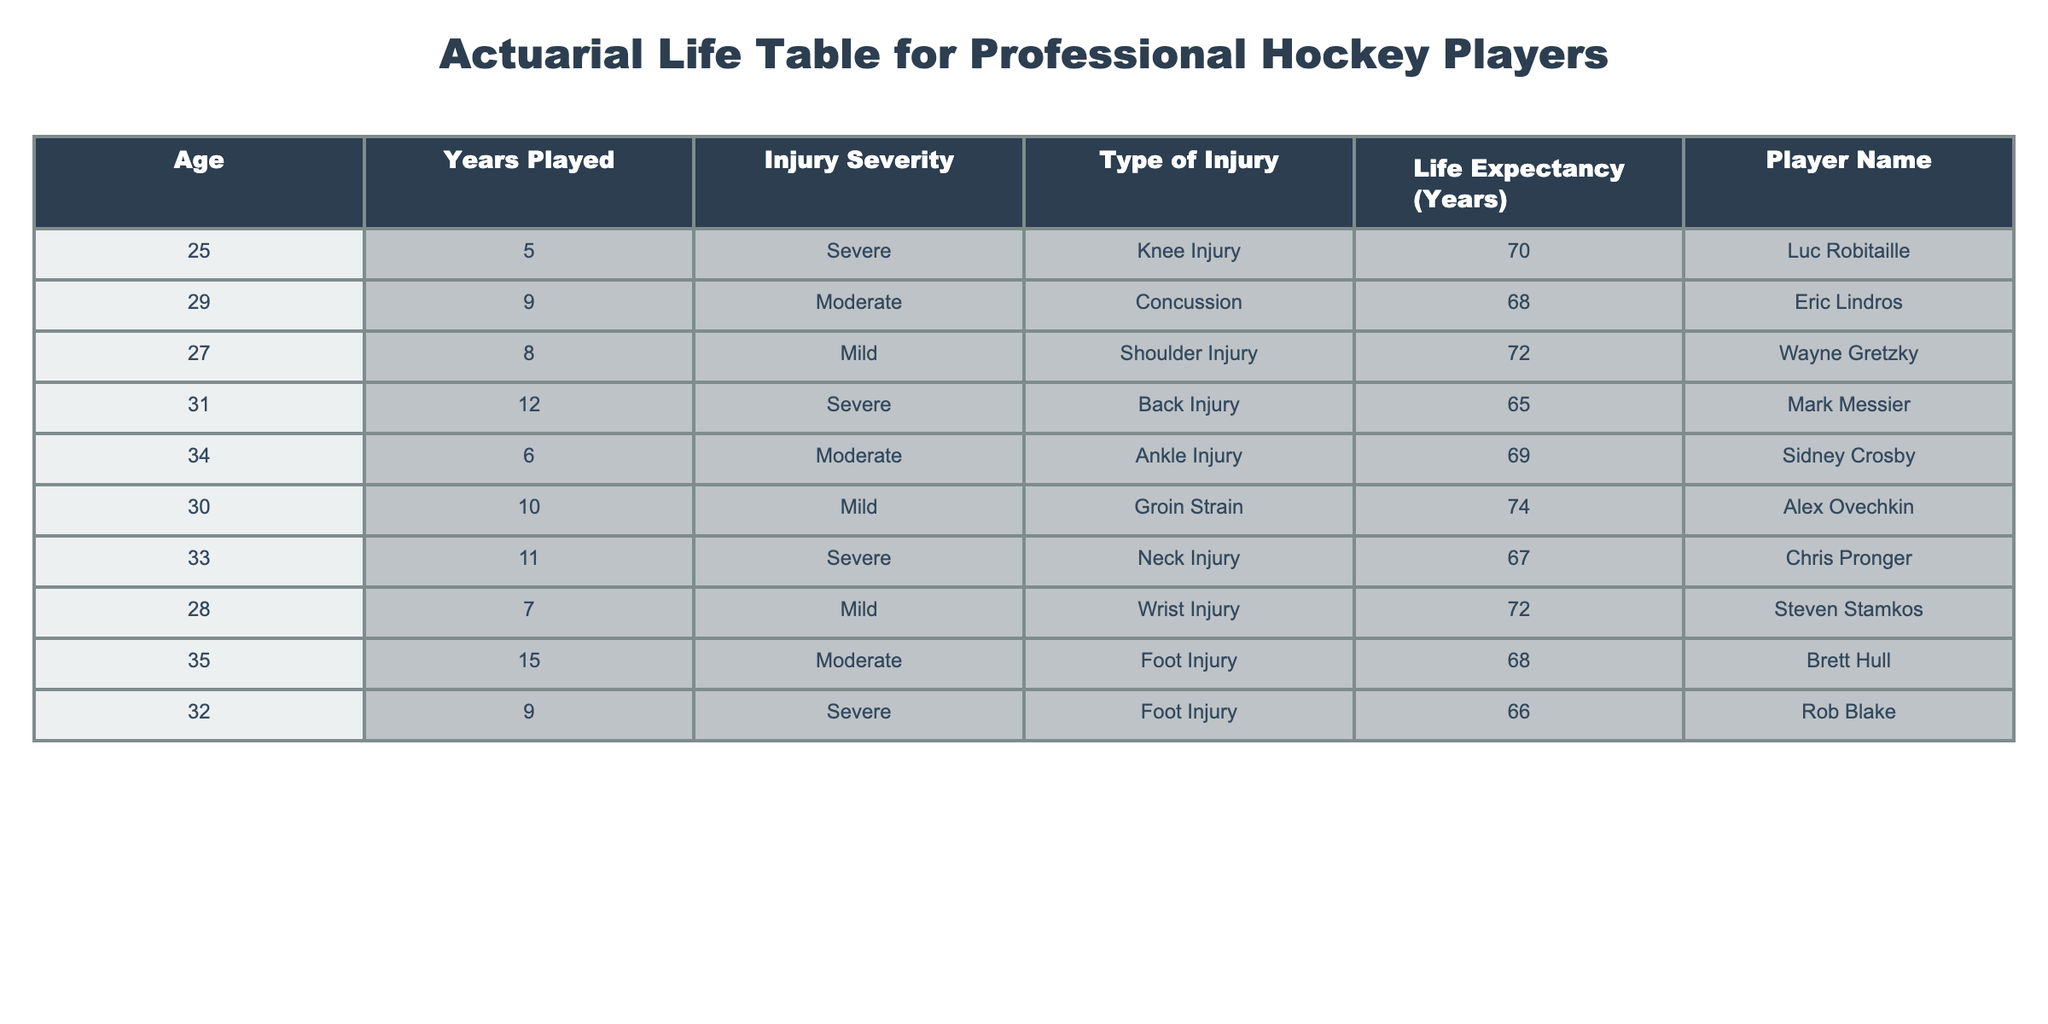What is the life expectancy of Luc Robitaille? Luc Robitaille's life expectancy, as stated in the table, is listed under the "Life Expectancy (Years)" column. His value is 70, which directly reflects the information provided.
Answer: 70 Which player has the highest life expectancy? To find this, we need to look at the "Life Expectancy (Years)" column and identify the maximum value. Upon reviewing the table, we see that Alex Ovechkin has the highest value of 74 years.
Answer: 74 What is the average life expectancy of players with severe injuries? We identify players with "Severe" under the "Injury Severity" column and note their life expectancies: Luc Robitaille (70), Mark Messier (65), Chris Pronger (67), and Rob Blake (66). Summing these gives 70 + 65 + 67 + 66 = 268. Now we divide this by the number of players (4) to find the average: 268 / 4 = 67.
Answer: 67 Is it true that all players with mild injuries have a life expectancy greater than 70 years? We check the "Injury Severity" column and find the players with "Mild" injuries: Wayne Gretzky (72), Alex Ovechkin (74), and Steven Stamkos (72). All three have values above 70 years; therefore, the statement is true.
Answer: Yes Which player had a career length of over 10 years and what was their life expectancy? Looking for players with "Years Played" greater than 10, we find Mark Messier (12) and Alex Ovechkin (10, exactly). The life expectancy for Mark Messier is 65 years, while for Alex Ovechkin it is 74 years. Since we focused on those over 10 years, the relevant answer is Mark Messier with 65 years.
Answer: 65 